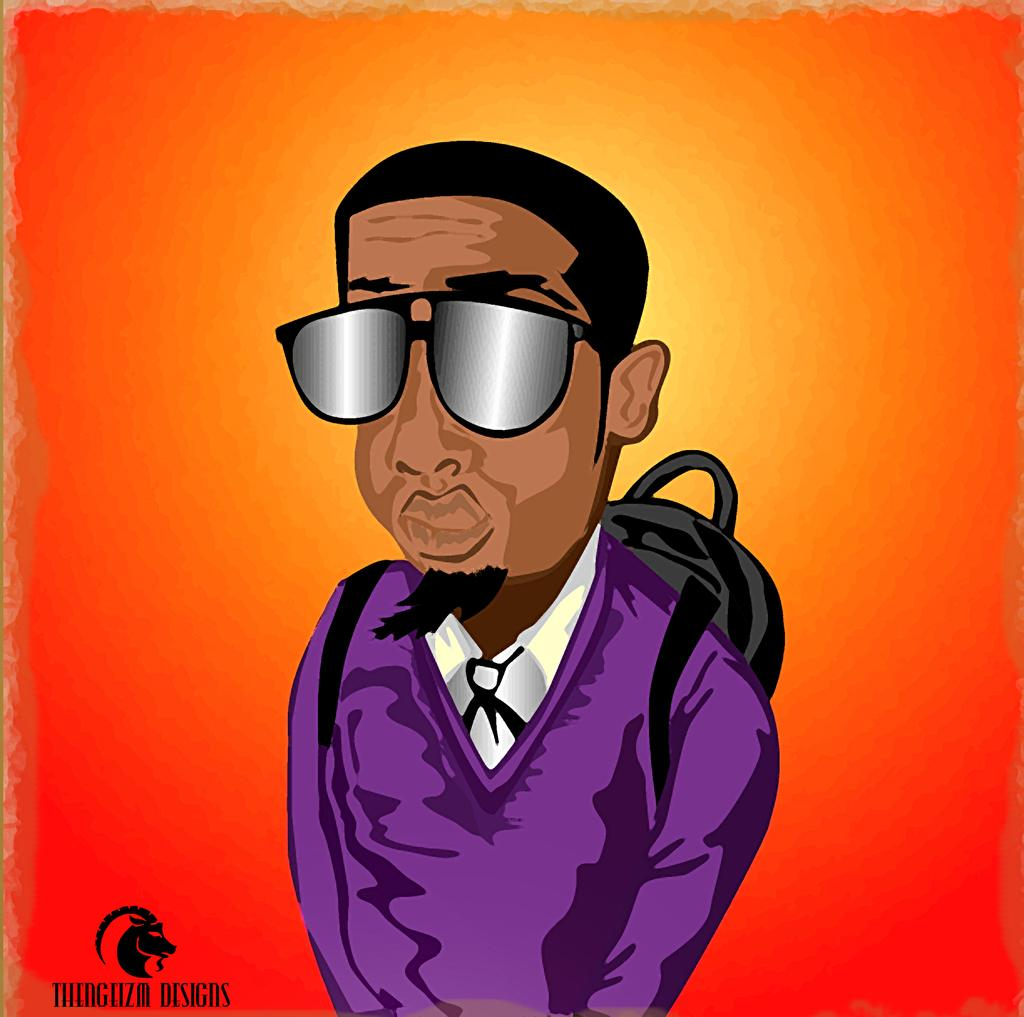What type of image is being described? The image is an animated image. What type of grain is being harvested in the image? There is no grain or harvesting activity present in the image, as it is an animated image. How many people are using the lift in the image? There is no lift present in the image, as it is an animated image. 